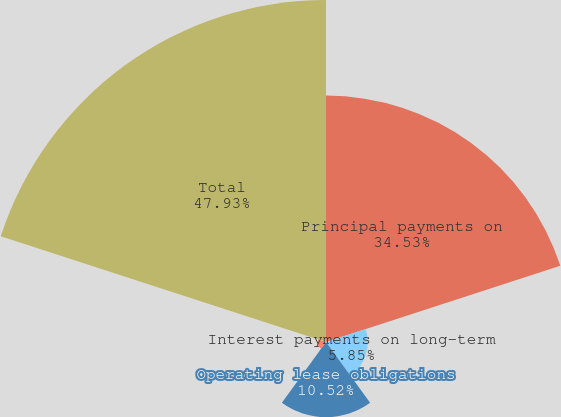Convert chart to OTSL. <chart><loc_0><loc_0><loc_500><loc_500><pie_chart><fcel>Principal payments on<fcel>Interest payments on long-term<fcel>Operating lease obligations<fcel>Capital lease obligations<fcel>Total<nl><fcel>34.53%<fcel>5.85%<fcel>10.52%<fcel>1.17%<fcel>47.93%<nl></chart> 